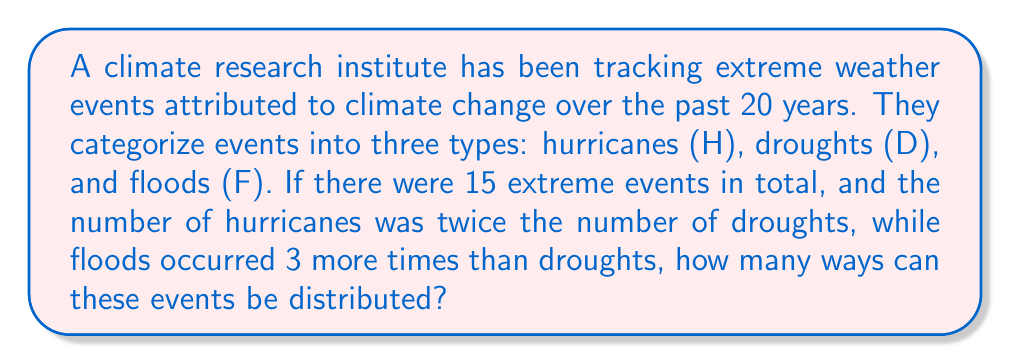Help me with this question. Let's approach this step-by-step:

1) Let $x$ be the number of droughts. Then:
   - Number of hurricanes = $2x$
   - Number of floods = $x + 3$

2) We know the total number of events is 15, so we can set up an equation:
   $x + 2x + (x + 3) = 15$

3) Simplify the equation:
   $4x + 3 = 15$

4) Solve for $x$:
   $4x = 12$
   $x = 3$

5) Now we know:
   - Droughts (D) = 3
   - Hurricanes (H) = $2 * 3 = 6$
   - Floods (F) = $3 + 3 = 6$

6) This is a combination problem. We need to calculate the number of ways to arrange 15 events, where:
   - 3 are identical (D)
   - 6 are identical (H)
   - 6 are identical (F)

7) This is given by the multinomial coefficient:

   $$\binom{15}{3,6,6} = \frac{15!}{3!6!6!}$$

8) Calculate:
   $$\frac{15!}{3!6!6!} = \frac{15 * 14 * 13 * 12 * 11 * 10 * 9!}{(3 * 2 * 1) * (6 * 5 * 4 * 3 * 2 * 1) * (6 * 5 * 4 * 3 * 2 * 1)}$$

9) Simplify:
   $$\frac{15 * 14 * 13 * 12 * 11 * 10}{6 * 5 * 4 * 3 * 2 * 1} = 455$$

Therefore, there are 455 ways to distribute these events.
Answer: 455 